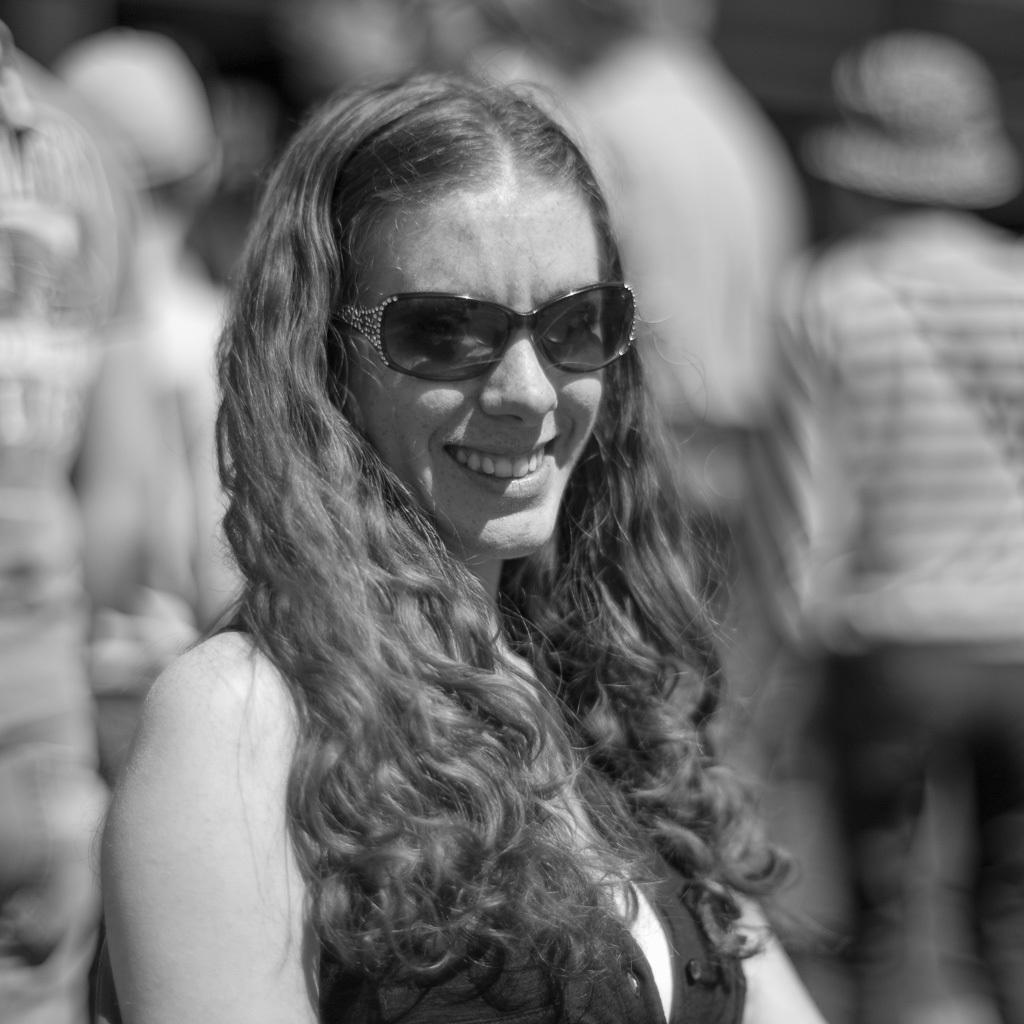How would you summarize this image in a sentence or two? This is a black and white picture. In the middle of the picture we can see a woman and she is smiling. There is a blur background and we can see people. 